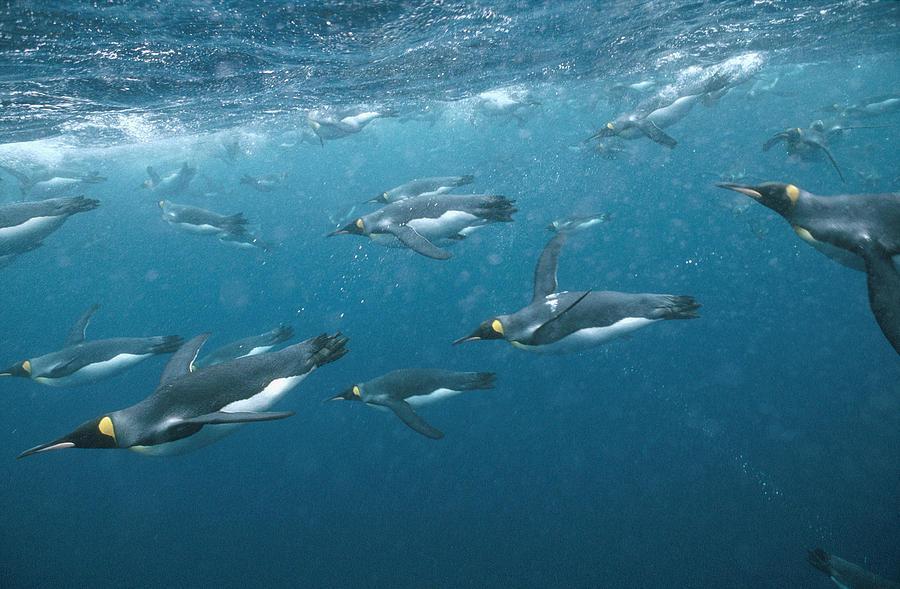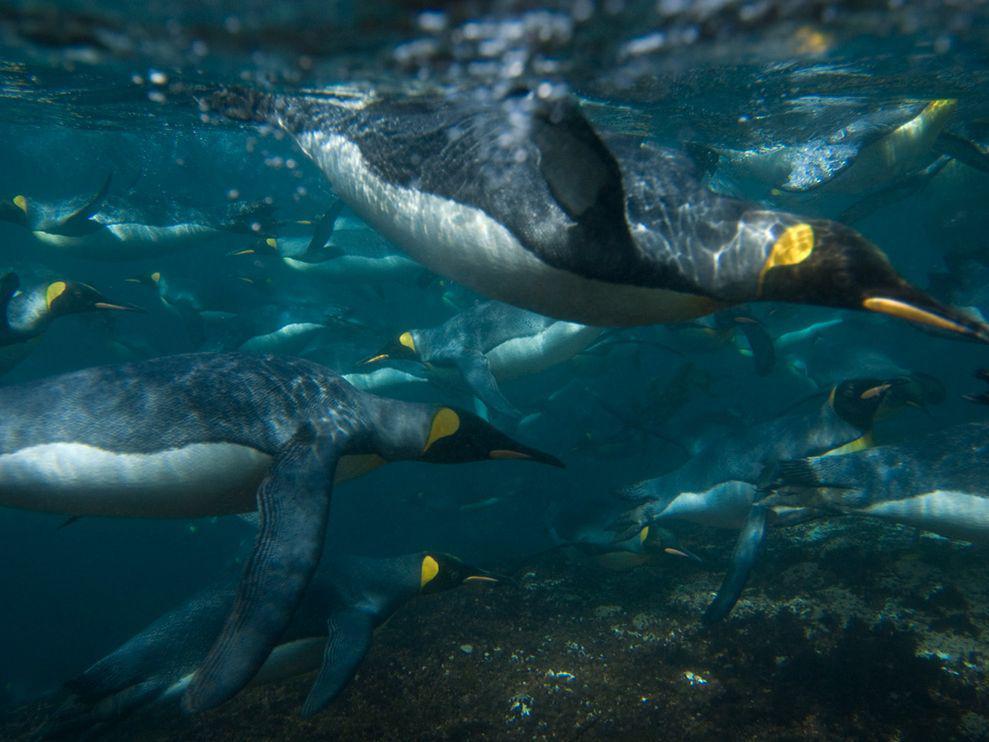The first image is the image on the left, the second image is the image on the right. Considering the images on both sides, is "There is no more than two penguins swimming underwater in the right image." valid? Answer yes or no. No. The first image is the image on the left, the second image is the image on the right. Assess this claim about the two images: "There are more than 10 penguins swimming.". Correct or not? Answer yes or no. Yes. 